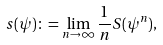Convert formula to latex. <formula><loc_0><loc_0><loc_500><loc_500>s ( \psi ) \colon = \lim _ { n \to \infty } \frac { 1 } { n } S ( \psi ^ { n } ) ,</formula> 